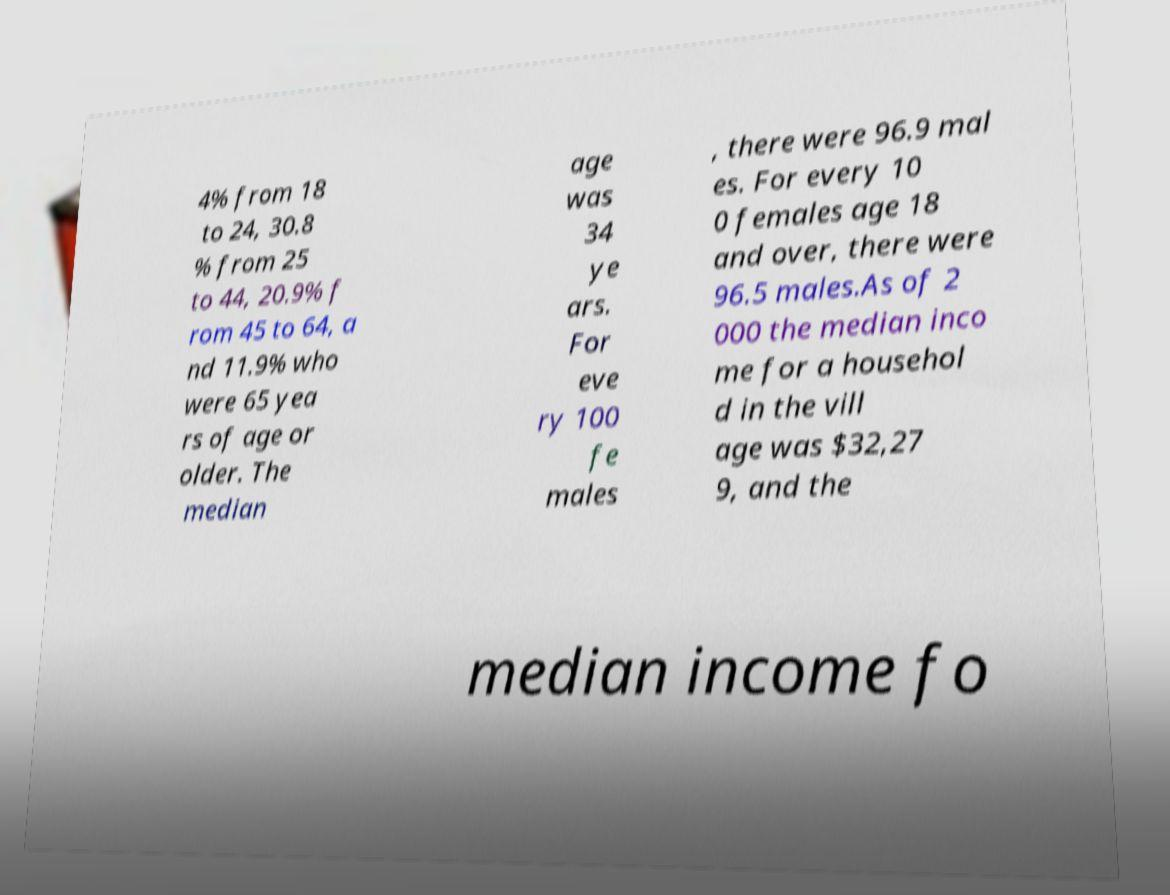Please read and relay the text visible in this image. What does it say? 4% from 18 to 24, 30.8 % from 25 to 44, 20.9% f rom 45 to 64, a nd 11.9% who were 65 yea rs of age or older. The median age was 34 ye ars. For eve ry 100 fe males , there were 96.9 mal es. For every 10 0 females age 18 and over, there were 96.5 males.As of 2 000 the median inco me for a househol d in the vill age was $32,27 9, and the median income fo 